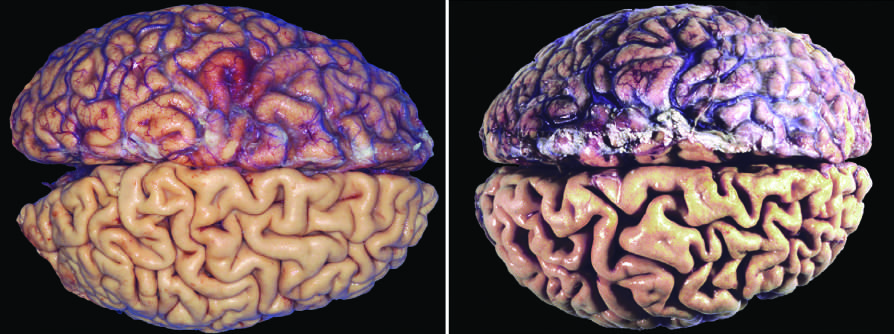what of the brain is caused by aging?
Answer the question using a single word or phrase. Atrophy 